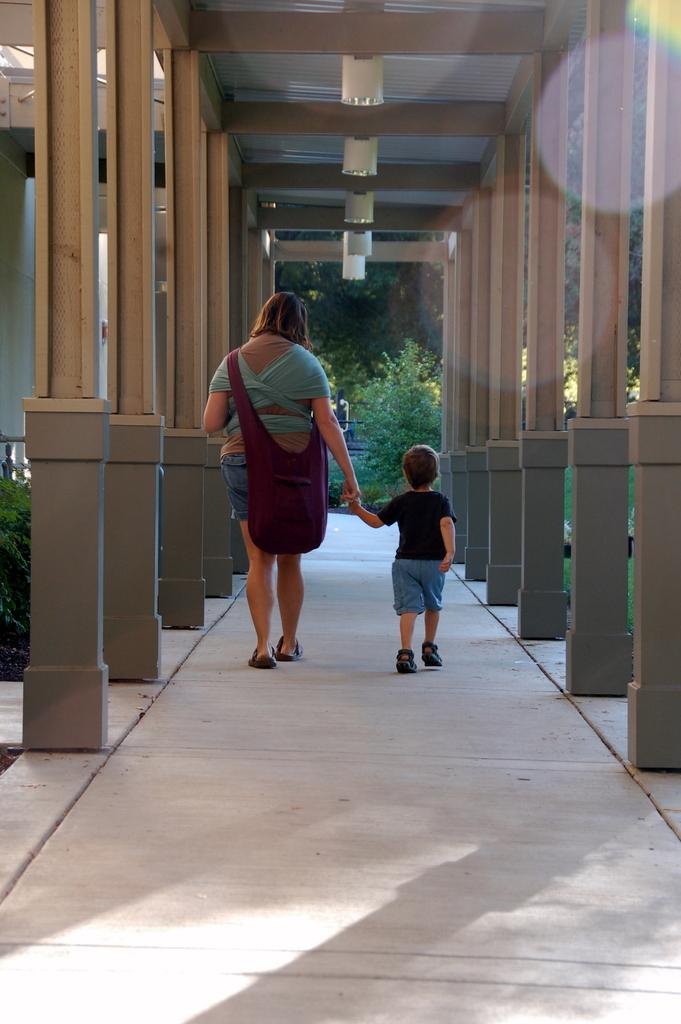Who can be seen in the image? There is a woman and a boy in the image. What are the woman and boy doing in the image? The woman and boy are walking on a path in the image. What is the woman carrying in the image? The woman is carrying a bag in the image. What additional features can be seen in the image? There are pillories and plants visible in the image. What type of joke is the woman telling the boy in the image? There is no indication in the image that the woman is telling a joke to the boy. --- Facts: 1. There is a car in the image. 2. The car is red. 3. The car has four wheels. 4. There are people in the car. 5. The car is parked on the street. Absurd Topics: parrot, dance, ocean Conversation: What is the main subject of the image? The main subject of the image is a car. What color is the car? The car is red. How many wheels does the car have? The car has four wheels. Are there any people inside the car? Yes, there are people in the car. Where is the car located in the image? The car is parked on the street. Reasoning: Let's think step by step in order to produce the conversation. We start by identifying the main subject of the image, which is the car. Then, we describe the car's color and the number of wheels it has. Next, we mention the presence of people inside the car. Finally, we describe the car's location, which is parked on the street. Absurd Question/Answer: Can you see a parrot dancing in the ocean in the image? No, there is no parrot dancing in the ocean in the image. 